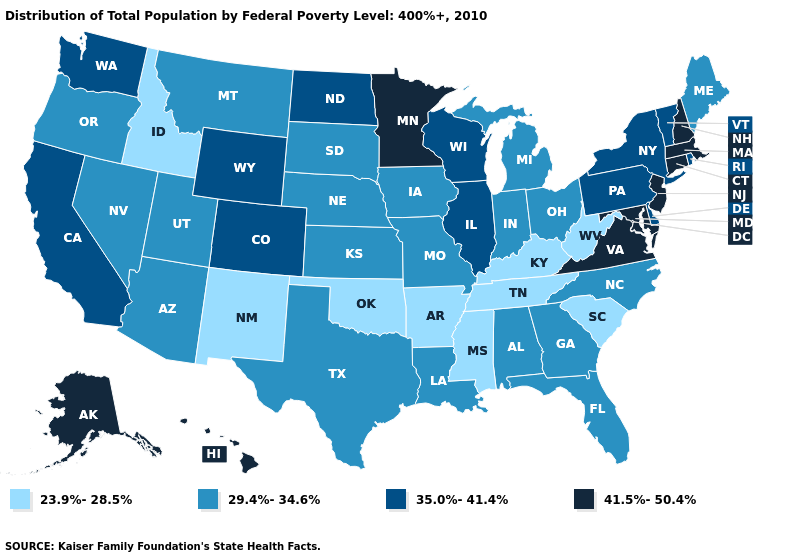Is the legend a continuous bar?
Keep it brief. No. Does Massachusetts have a lower value than Arizona?
Give a very brief answer. No. How many symbols are there in the legend?
Answer briefly. 4. Name the states that have a value in the range 35.0%-41.4%?
Give a very brief answer. California, Colorado, Delaware, Illinois, New York, North Dakota, Pennsylvania, Rhode Island, Vermont, Washington, Wisconsin, Wyoming. What is the highest value in the USA?
Keep it brief. 41.5%-50.4%. Does Arkansas have the lowest value in the USA?
Answer briefly. Yes. Does the first symbol in the legend represent the smallest category?
Quick response, please. Yes. Does Ohio have the lowest value in the USA?
Answer briefly. No. Which states have the lowest value in the USA?
Concise answer only. Arkansas, Idaho, Kentucky, Mississippi, New Mexico, Oklahoma, South Carolina, Tennessee, West Virginia. Does Georgia have the lowest value in the South?
Keep it brief. No. Is the legend a continuous bar?
Give a very brief answer. No. Among the states that border Nebraska , which have the highest value?
Keep it brief. Colorado, Wyoming. Name the states that have a value in the range 41.5%-50.4%?
Keep it brief. Alaska, Connecticut, Hawaii, Maryland, Massachusetts, Minnesota, New Hampshire, New Jersey, Virginia. Name the states that have a value in the range 29.4%-34.6%?
Be succinct. Alabama, Arizona, Florida, Georgia, Indiana, Iowa, Kansas, Louisiana, Maine, Michigan, Missouri, Montana, Nebraska, Nevada, North Carolina, Ohio, Oregon, South Dakota, Texas, Utah. 